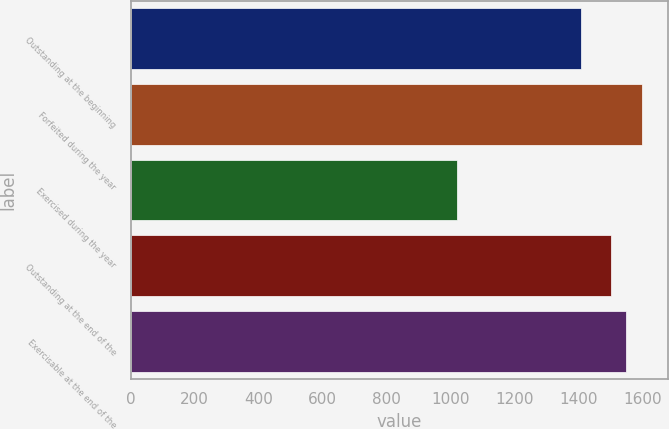Convert chart. <chart><loc_0><loc_0><loc_500><loc_500><bar_chart><fcel>Outstanding at the beginning<fcel>Forfeited during the year<fcel>Exercised during the year<fcel>Outstanding at the end of the<fcel>Exercisable at the end of the<nl><fcel>1406<fcel>1597.67<fcel>1019.94<fcel>1498.75<fcel>1548.21<nl></chart> 